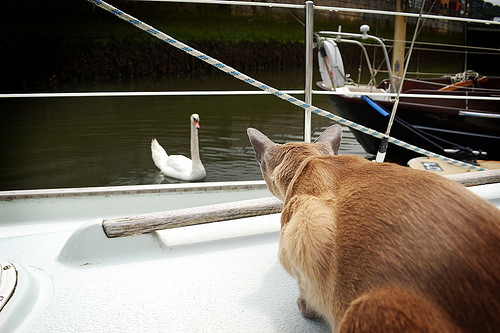<image>
Is there a cat behind the duck? No. The cat is not behind the duck. From this viewpoint, the cat appears to be positioned elsewhere in the scene. Is the cat next to the swan? No. The cat is not positioned next to the swan. They are located in different areas of the scene. Is the cat in front of the swan? Yes. The cat is positioned in front of the swan, appearing closer to the camera viewpoint. 